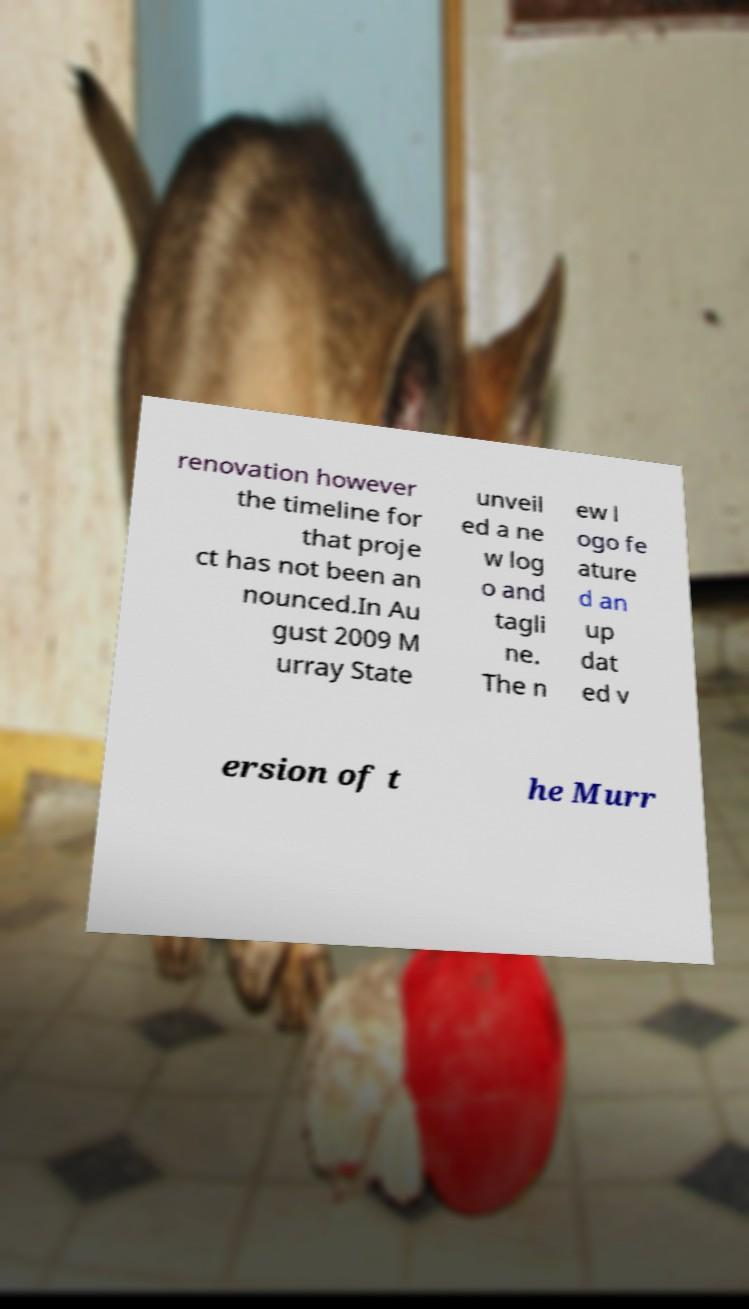Please identify and transcribe the text found in this image. renovation however the timeline for that proje ct has not been an nounced.In Au gust 2009 M urray State unveil ed a ne w log o and tagli ne. The n ew l ogo fe ature d an up dat ed v ersion of t he Murr 